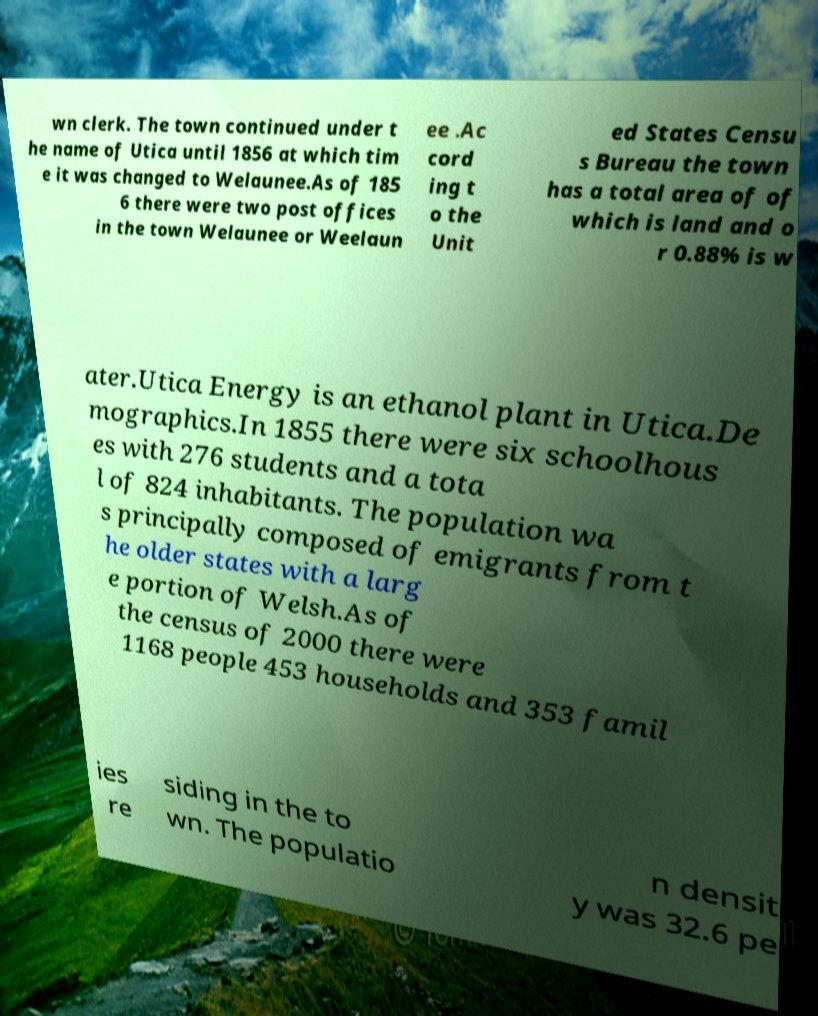There's text embedded in this image that I need extracted. Can you transcribe it verbatim? wn clerk. The town continued under t he name of Utica until 1856 at which tim e it was changed to Welaunee.As of 185 6 there were two post offices in the town Welaunee or Weelaun ee .Ac cord ing t o the Unit ed States Censu s Bureau the town has a total area of of which is land and o r 0.88% is w ater.Utica Energy is an ethanol plant in Utica.De mographics.In 1855 there were six schoolhous es with 276 students and a tota l of 824 inhabitants. The population wa s principally composed of emigrants from t he older states with a larg e portion of Welsh.As of the census of 2000 there were 1168 people 453 households and 353 famil ies re siding in the to wn. The populatio n densit y was 32.6 pe 